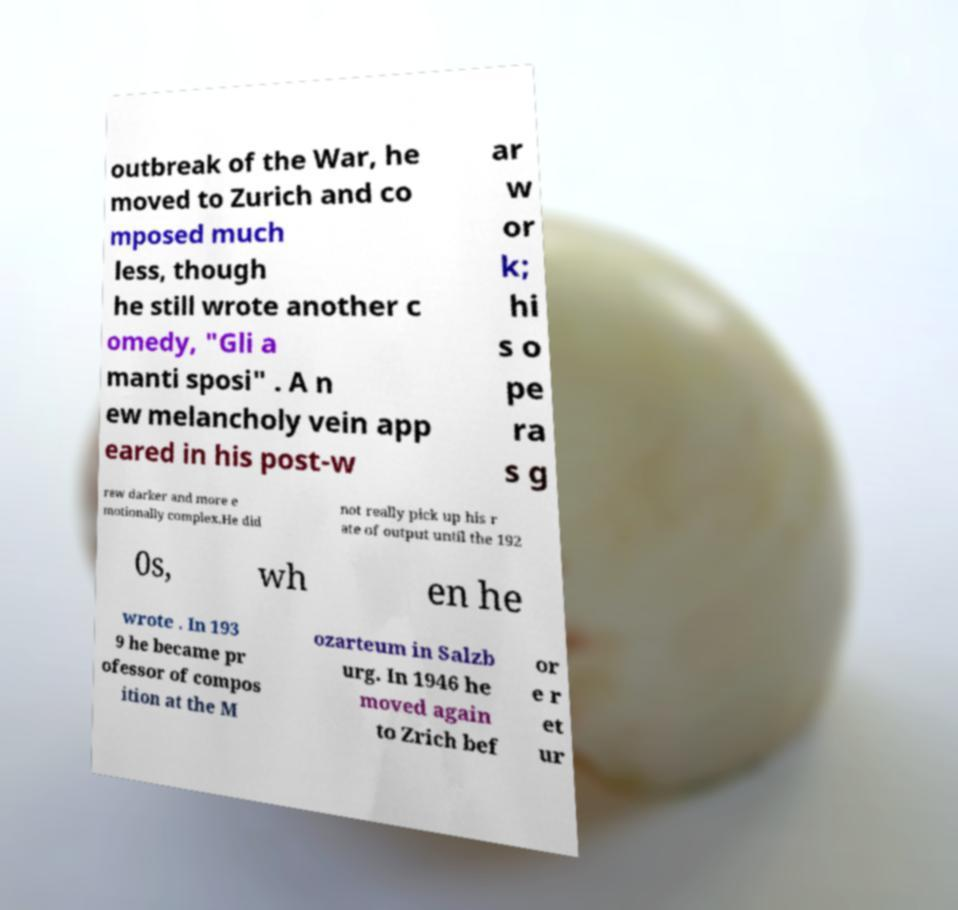Can you accurately transcribe the text from the provided image for me? outbreak of the War, he moved to Zurich and co mposed much less, though he still wrote another c omedy, "Gli a manti sposi" . A n ew melancholy vein app eared in his post-w ar w or k; hi s o pe ra s g rew darker and more e motionally complex.He did not really pick up his r ate of output until the 192 0s, wh en he wrote . In 193 9 he became pr ofessor of compos ition at the M ozarteum in Salzb urg. In 1946 he moved again to Zrich bef or e r et ur 